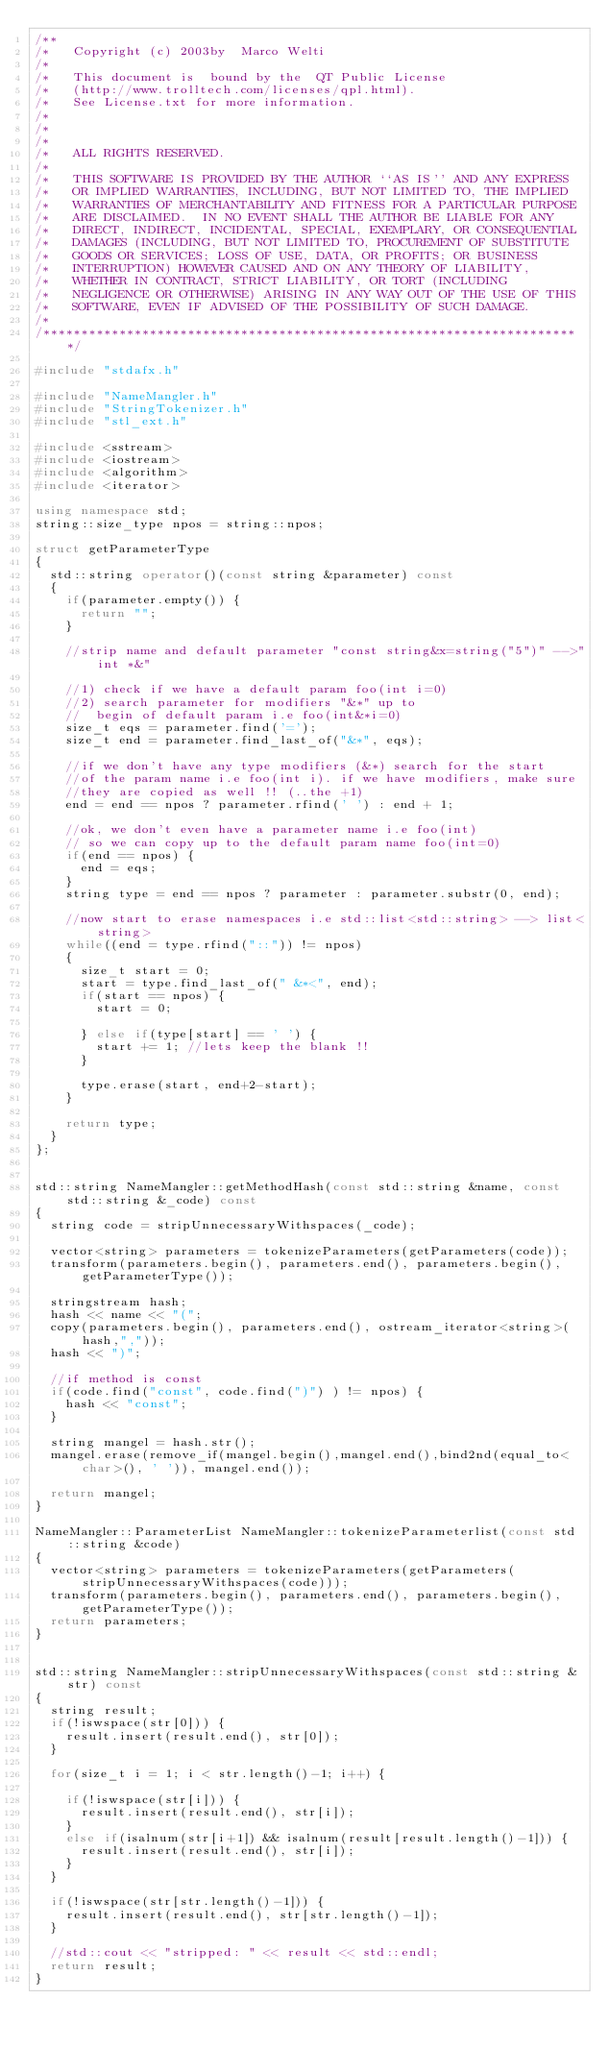<code> <loc_0><loc_0><loc_500><loc_500><_C++_>/**
/*   Copyright (c) 2003by  Marco Welti
/*
/*   This document is  bound by the  QT Public License
/*   (http://www.trolltech.com/licenses/qpl.html).
/*   See License.txt for more information.
/*
/*
/*
/*   ALL RIGHTS RESERVED.  
/* 
/*   THIS SOFTWARE IS PROVIDED BY THE AUTHOR ``AS IS'' AND ANY EXPRESS
/*   OR IMPLIED WARRANTIES, INCLUDING, BUT NOT LIMITED TO, THE IMPLIED
/*   WARRANTIES OF MERCHANTABILITY AND FITNESS FOR A PARTICULAR PURPOSE
/*   ARE DISCLAIMED.  IN NO EVENT SHALL THE AUTHOR BE LIABLE FOR ANY
/*   DIRECT, INDIRECT, INCIDENTAL, SPECIAL, EXEMPLARY, OR CONSEQUENTIAL
/*   DAMAGES (INCLUDING, BUT NOT LIMITED TO, PROCUREMENT OF SUBSTITUTE
/*   GOODS OR SERVICES; LOSS OF USE, DATA, OR PROFITS; OR BUSINESS
/*   INTERRUPTION) HOWEVER CAUSED AND ON ANY THEORY OF LIABILITY,
/*   WHETHER IN CONTRACT, STRICT LIABILITY, OR TORT (INCLUDING
/*   NEGLIGENCE OR OTHERWISE) ARISING IN ANY WAY OUT OF THE USE OF THIS
/*   SOFTWARE, EVEN IF ADVISED OF THE POSSIBILITY OF SUCH DAMAGE.
/* 
/***********************************************************************/

#include "stdafx.h"

#include "NameMangler.h"
#include "StringTokenizer.h"
#include "stl_ext.h"

#include <sstream>
#include <iostream>
#include <algorithm>
#include <iterator>

using namespace std;
string::size_type npos = string::npos;

struct getParameterType
{
  std::string operator()(const string &parameter) const
  {
    if(parameter.empty()) {
      return "";
    }
    
    //strip name and default parameter "const string&x=string("5")" -->"int *&"
    
    //1) check if we have a default param foo(int i=0)
    //2) search parameter for modifiers "&*" up to 
    //  begin of default param i.e foo(int&*i=0)
    size_t eqs = parameter.find('=');
    size_t end = parameter.find_last_of("&*", eqs);
    
    //if we don't have any type modifiers (&*) search for the start
    //of the param name i.e foo(int i). if we have modifiers, make sure
    //they are copied as well !! (..the +1)
    end = end == npos ? parameter.rfind(' ') : end + 1;
  
    //ok, we don't even have a parameter name i.e foo(int)
    // so we can copy up to the default param name foo(int=0)
    if(end == npos) {
      end = eqs;
    }
    string type = end == npos ? parameter : parameter.substr(0, end);

    //now start to erase namespaces i.e std::list<std::string> --> list<string>
    while((end = type.rfind("::")) != npos)
    {
      size_t start = 0;
      start = type.find_last_of(" &*<", end);
      if(start == npos) {
        start = 0;

      } else if(type[start] == ' ') {
        start += 1; //lets keep the blank !!
      }

      type.erase(start, end+2-start);
    }
   
    return type;  
  }
};


std::string NameMangler::getMethodHash(const std::string &name, const std::string &_code) const
{
  string code = stripUnnecessaryWithspaces(_code);

  vector<string> parameters = tokenizeParameters(getParameters(code));
  transform(parameters.begin(), parameters.end(), parameters.begin(),getParameterType());

  stringstream hash;
  hash << name << "(";
  copy(parameters.begin(), parameters.end(), ostream_iterator<string>(hash,","));
  hash << ")";

  //if method is const
  if(code.find("const", code.find(")") ) != npos) {
    hash << "const";
  }

  string mangel = hash.str();
  mangel.erase(remove_if(mangel.begin(),mangel.end(),bind2nd(equal_to<char>(), ' ')), mangel.end());

  return mangel;
}

NameMangler::ParameterList NameMangler::tokenizeParameterlist(const std::string &code)
{
  vector<string> parameters = tokenizeParameters(getParameters(stripUnnecessaryWithspaces(code)));
  transform(parameters.begin(), parameters.end(), parameters.begin(),getParameterType());
  return parameters;
}


std::string NameMangler::stripUnnecessaryWithspaces(const std::string &str) const
{
  string result;
  if(!iswspace(str[0])) {
    result.insert(result.end(), str[0]);
  }

  for(size_t i = 1; i < str.length()-1; i++) {

    if(!iswspace(str[i])) {
      result.insert(result.end(), str[i]);
    } 
    else if(isalnum(str[i+1]) && isalnum(result[result.length()-1])) {
      result.insert(result.end(), str[i]);
    } 
  }

  if(!iswspace(str[str.length()-1])) {
    result.insert(result.end(), str[str.length()-1]);
  }

  //std::cout << "stripped: " << result << std::endl;
  return result;
}
</code> 